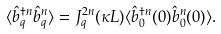Convert formula to latex. <formula><loc_0><loc_0><loc_500><loc_500>\langle \hat { b } _ { q } ^ { \dagger n } \hat { b } _ { q } ^ { n } \rangle = J _ { q } ^ { 2 n } ( \kappa L ) \langle \hat { b } _ { 0 } ^ { \dagger n } ( 0 ) \hat { b } _ { 0 } ^ { n } ( 0 ) \rangle .</formula> 